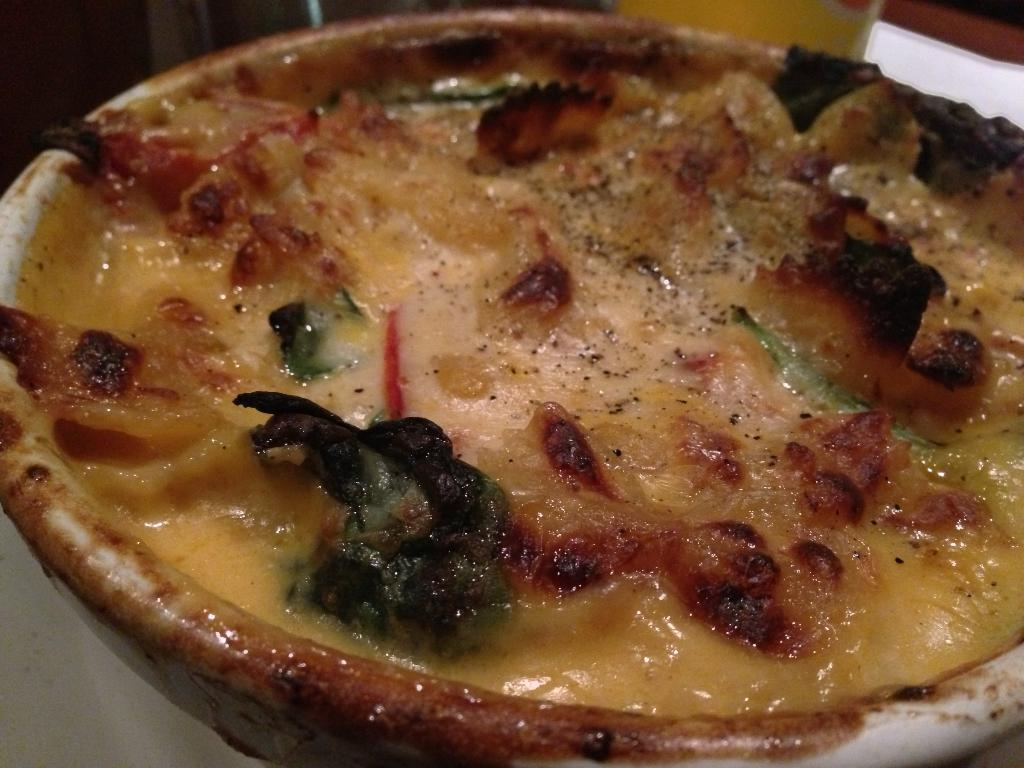What is the main food item in the image? There is a food item in a bowl on a plate in the image. Can you describe the object in the background of the image? Unfortunately, the provided facts do not give enough information to describe the object in the background. How many quivers are visible in the image? There are no quivers present in the image. What decision was made by the person in the image? There is no person present in the image, so it is impossible to determine any decisions made. 